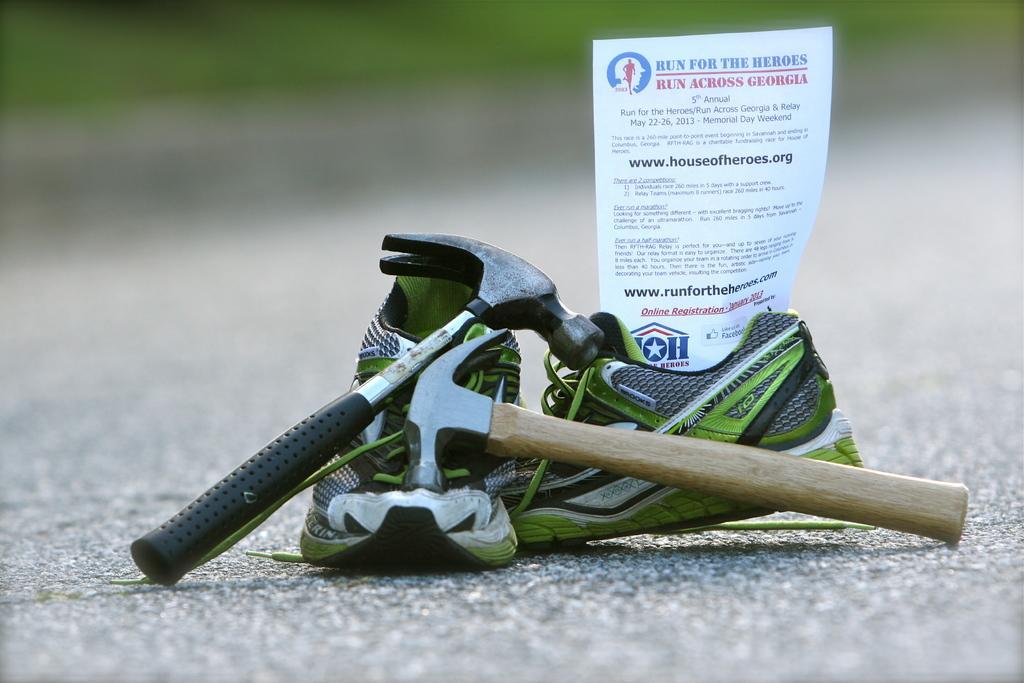Please provide a concise description of this image. In this picture we can see shoes, paper and framing hammers. 